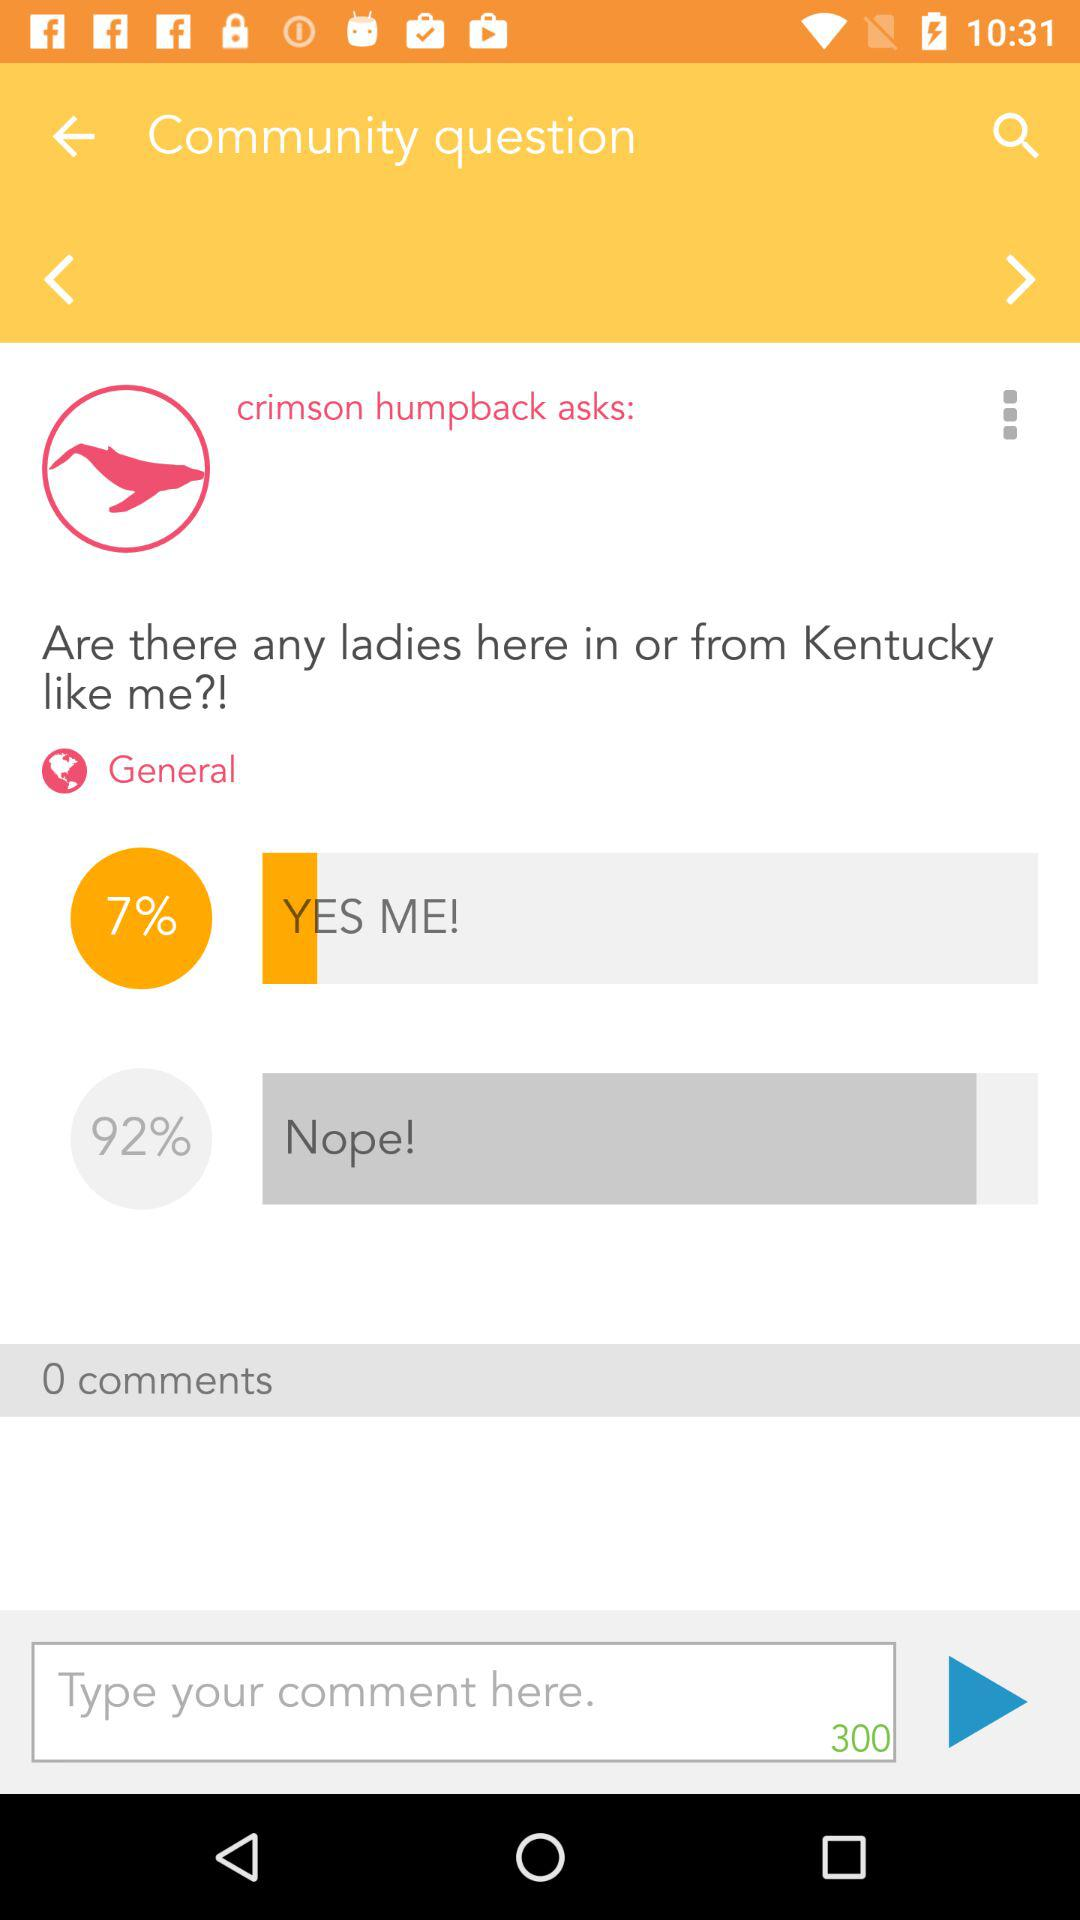What is the percentage of the answer Nope? The percentage is 92. 